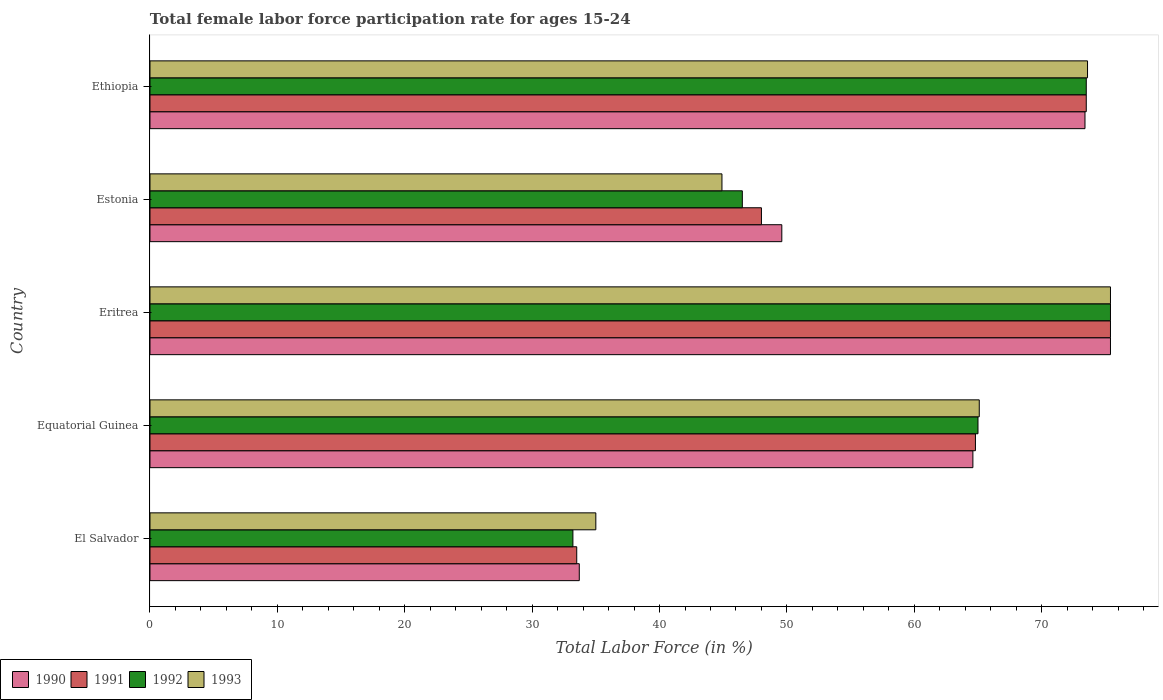How many different coloured bars are there?
Your answer should be very brief. 4. Are the number of bars on each tick of the Y-axis equal?
Provide a succinct answer. Yes. How many bars are there on the 1st tick from the top?
Provide a short and direct response. 4. What is the label of the 4th group of bars from the top?
Your answer should be compact. Equatorial Guinea. What is the female labor force participation rate in 1992 in Equatorial Guinea?
Provide a succinct answer. 65. Across all countries, what is the maximum female labor force participation rate in 1991?
Keep it short and to the point. 75.4. Across all countries, what is the minimum female labor force participation rate in 1991?
Keep it short and to the point. 33.5. In which country was the female labor force participation rate in 1991 maximum?
Your answer should be very brief. Eritrea. In which country was the female labor force participation rate in 1993 minimum?
Provide a short and direct response. El Salvador. What is the total female labor force participation rate in 1992 in the graph?
Provide a succinct answer. 293.6. What is the difference between the female labor force participation rate in 1991 in Estonia and the female labor force participation rate in 1992 in Ethiopia?
Make the answer very short. -25.5. What is the average female labor force participation rate in 1990 per country?
Keep it short and to the point. 59.34. What is the difference between the female labor force participation rate in 1992 and female labor force participation rate in 1990 in Equatorial Guinea?
Offer a terse response. 0.4. In how many countries, is the female labor force participation rate in 1992 greater than 20 %?
Offer a very short reply. 5. What is the ratio of the female labor force participation rate in 1990 in Equatorial Guinea to that in Eritrea?
Your answer should be compact. 0.86. What is the difference between the highest and the second highest female labor force participation rate in 1991?
Make the answer very short. 1.9. What is the difference between the highest and the lowest female labor force participation rate in 1992?
Your answer should be very brief. 42.2. In how many countries, is the female labor force participation rate in 1990 greater than the average female labor force participation rate in 1990 taken over all countries?
Your answer should be compact. 3. Is the sum of the female labor force participation rate in 1992 in El Salvador and Eritrea greater than the maximum female labor force participation rate in 1991 across all countries?
Give a very brief answer. Yes. How many bars are there?
Ensure brevity in your answer.  20. How many countries are there in the graph?
Keep it short and to the point. 5. Are the values on the major ticks of X-axis written in scientific E-notation?
Make the answer very short. No. Does the graph contain grids?
Ensure brevity in your answer.  No. Where does the legend appear in the graph?
Provide a short and direct response. Bottom left. What is the title of the graph?
Give a very brief answer. Total female labor force participation rate for ages 15-24. What is the label or title of the X-axis?
Provide a succinct answer. Total Labor Force (in %). What is the label or title of the Y-axis?
Provide a succinct answer. Country. What is the Total Labor Force (in %) of 1990 in El Salvador?
Provide a succinct answer. 33.7. What is the Total Labor Force (in %) of 1991 in El Salvador?
Your answer should be compact. 33.5. What is the Total Labor Force (in %) of 1992 in El Salvador?
Keep it short and to the point. 33.2. What is the Total Labor Force (in %) in 1990 in Equatorial Guinea?
Provide a succinct answer. 64.6. What is the Total Labor Force (in %) of 1991 in Equatorial Guinea?
Make the answer very short. 64.8. What is the Total Labor Force (in %) of 1993 in Equatorial Guinea?
Keep it short and to the point. 65.1. What is the Total Labor Force (in %) in 1990 in Eritrea?
Give a very brief answer. 75.4. What is the Total Labor Force (in %) in 1991 in Eritrea?
Make the answer very short. 75.4. What is the Total Labor Force (in %) of 1992 in Eritrea?
Ensure brevity in your answer.  75.4. What is the Total Labor Force (in %) of 1993 in Eritrea?
Provide a short and direct response. 75.4. What is the Total Labor Force (in %) in 1990 in Estonia?
Make the answer very short. 49.6. What is the Total Labor Force (in %) of 1992 in Estonia?
Offer a terse response. 46.5. What is the Total Labor Force (in %) in 1993 in Estonia?
Keep it short and to the point. 44.9. What is the Total Labor Force (in %) in 1990 in Ethiopia?
Your response must be concise. 73.4. What is the Total Labor Force (in %) of 1991 in Ethiopia?
Your response must be concise. 73.5. What is the Total Labor Force (in %) of 1992 in Ethiopia?
Your answer should be very brief. 73.5. What is the Total Labor Force (in %) of 1993 in Ethiopia?
Provide a short and direct response. 73.6. Across all countries, what is the maximum Total Labor Force (in %) of 1990?
Provide a succinct answer. 75.4. Across all countries, what is the maximum Total Labor Force (in %) of 1991?
Your response must be concise. 75.4. Across all countries, what is the maximum Total Labor Force (in %) of 1992?
Offer a terse response. 75.4. Across all countries, what is the maximum Total Labor Force (in %) in 1993?
Provide a short and direct response. 75.4. Across all countries, what is the minimum Total Labor Force (in %) of 1990?
Make the answer very short. 33.7. Across all countries, what is the minimum Total Labor Force (in %) of 1991?
Offer a very short reply. 33.5. Across all countries, what is the minimum Total Labor Force (in %) of 1992?
Your answer should be compact. 33.2. What is the total Total Labor Force (in %) of 1990 in the graph?
Offer a very short reply. 296.7. What is the total Total Labor Force (in %) in 1991 in the graph?
Your answer should be very brief. 295.2. What is the total Total Labor Force (in %) in 1992 in the graph?
Your response must be concise. 293.6. What is the total Total Labor Force (in %) in 1993 in the graph?
Your answer should be compact. 294. What is the difference between the Total Labor Force (in %) in 1990 in El Salvador and that in Equatorial Guinea?
Your answer should be compact. -30.9. What is the difference between the Total Labor Force (in %) of 1991 in El Salvador and that in Equatorial Guinea?
Provide a short and direct response. -31.3. What is the difference between the Total Labor Force (in %) of 1992 in El Salvador and that in Equatorial Guinea?
Provide a succinct answer. -31.8. What is the difference between the Total Labor Force (in %) in 1993 in El Salvador and that in Equatorial Guinea?
Keep it short and to the point. -30.1. What is the difference between the Total Labor Force (in %) in 1990 in El Salvador and that in Eritrea?
Provide a succinct answer. -41.7. What is the difference between the Total Labor Force (in %) of 1991 in El Salvador and that in Eritrea?
Make the answer very short. -41.9. What is the difference between the Total Labor Force (in %) of 1992 in El Salvador and that in Eritrea?
Keep it short and to the point. -42.2. What is the difference between the Total Labor Force (in %) of 1993 in El Salvador and that in Eritrea?
Offer a terse response. -40.4. What is the difference between the Total Labor Force (in %) of 1990 in El Salvador and that in Estonia?
Your answer should be compact. -15.9. What is the difference between the Total Labor Force (in %) of 1991 in El Salvador and that in Estonia?
Ensure brevity in your answer.  -14.5. What is the difference between the Total Labor Force (in %) in 1993 in El Salvador and that in Estonia?
Make the answer very short. -9.9. What is the difference between the Total Labor Force (in %) in 1990 in El Salvador and that in Ethiopia?
Your answer should be compact. -39.7. What is the difference between the Total Labor Force (in %) in 1992 in El Salvador and that in Ethiopia?
Make the answer very short. -40.3. What is the difference between the Total Labor Force (in %) in 1993 in El Salvador and that in Ethiopia?
Ensure brevity in your answer.  -38.6. What is the difference between the Total Labor Force (in %) in 1991 in Equatorial Guinea and that in Eritrea?
Your response must be concise. -10.6. What is the difference between the Total Labor Force (in %) of 1993 in Equatorial Guinea and that in Eritrea?
Give a very brief answer. -10.3. What is the difference between the Total Labor Force (in %) in 1990 in Equatorial Guinea and that in Estonia?
Your answer should be very brief. 15. What is the difference between the Total Labor Force (in %) in 1993 in Equatorial Guinea and that in Estonia?
Your response must be concise. 20.2. What is the difference between the Total Labor Force (in %) of 1991 in Equatorial Guinea and that in Ethiopia?
Your answer should be compact. -8.7. What is the difference between the Total Labor Force (in %) of 1993 in Equatorial Guinea and that in Ethiopia?
Offer a very short reply. -8.5. What is the difference between the Total Labor Force (in %) in 1990 in Eritrea and that in Estonia?
Give a very brief answer. 25.8. What is the difference between the Total Labor Force (in %) in 1991 in Eritrea and that in Estonia?
Offer a very short reply. 27.4. What is the difference between the Total Labor Force (in %) in 1992 in Eritrea and that in Estonia?
Your response must be concise. 28.9. What is the difference between the Total Labor Force (in %) of 1993 in Eritrea and that in Estonia?
Provide a short and direct response. 30.5. What is the difference between the Total Labor Force (in %) in 1990 in Eritrea and that in Ethiopia?
Offer a terse response. 2. What is the difference between the Total Labor Force (in %) of 1992 in Eritrea and that in Ethiopia?
Your response must be concise. 1.9. What is the difference between the Total Labor Force (in %) of 1993 in Eritrea and that in Ethiopia?
Your answer should be compact. 1.8. What is the difference between the Total Labor Force (in %) in 1990 in Estonia and that in Ethiopia?
Give a very brief answer. -23.8. What is the difference between the Total Labor Force (in %) of 1991 in Estonia and that in Ethiopia?
Provide a succinct answer. -25.5. What is the difference between the Total Labor Force (in %) of 1993 in Estonia and that in Ethiopia?
Offer a very short reply. -28.7. What is the difference between the Total Labor Force (in %) in 1990 in El Salvador and the Total Labor Force (in %) in 1991 in Equatorial Guinea?
Provide a short and direct response. -31.1. What is the difference between the Total Labor Force (in %) in 1990 in El Salvador and the Total Labor Force (in %) in 1992 in Equatorial Guinea?
Ensure brevity in your answer.  -31.3. What is the difference between the Total Labor Force (in %) in 1990 in El Salvador and the Total Labor Force (in %) in 1993 in Equatorial Guinea?
Give a very brief answer. -31.4. What is the difference between the Total Labor Force (in %) in 1991 in El Salvador and the Total Labor Force (in %) in 1992 in Equatorial Guinea?
Your answer should be very brief. -31.5. What is the difference between the Total Labor Force (in %) of 1991 in El Salvador and the Total Labor Force (in %) of 1993 in Equatorial Guinea?
Your response must be concise. -31.6. What is the difference between the Total Labor Force (in %) of 1992 in El Salvador and the Total Labor Force (in %) of 1993 in Equatorial Guinea?
Your response must be concise. -31.9. What is the difference between the Total Labor Force (in %) in 1990 in El Salvador and the Total Labor Force (in %) in 1991 in Eritrea?
Make the answer very short. -41.7. What is the difference between the Total Labor Force (in %) of 1990 in El Salvador and the Total Labor Force (in %) of 1992 in Eritrea?
Your answer should be compact. -41.7. What is the difference between the Total Labor Force (in %) in 1990 in El Salvador and the Total Labor Force (in %) in 1993 in Eritrea?
Provide a succinct answer. -41.7. What is the difference between the Total Labor Force (in %) in 1991 in El Salvador and the Total Labor Force (in %) in 1992 in Eritrea?
Your answer should be compact. -41.9. What is the difference between the Total Labor Force (in %) in 1991 in El Salvador and the Total Labor Force (in %) in 1993 in Eritrea?
Your answer should be compact. -41.9. What is the difference between the Total Labor Force (in %) in 1992 in El Salvador and the Total Labor Force (in %) in 1993 in Eritrea?
Offer a terse response. -42.2. What is the difference between the Total Labor Force (in %) in 1990 in El Salvador and the Total Labor Force (in %) in 1991 in Estonia?
Offer a terse response. -14.3. What is the difference between the Total Labor Force (in %) in 1990 in El Salvador and the Total Labor Force (in %) in 1992 in Estonia?
Offer a very short reply. -12.8. What is the difference between the Total Labor Force (in %) of 1990 in El Salvador and the Total Labor Force (in %) of 1993 in Estonia?
Offer a terse response. -11.2. What is the difference between the Total Labor Force (in %) of 1991 in El Salvador and the Total Labor Force (in %) of 1993 in Estonia?
Ensure brevity in your answer.  -11.4. What is the difference between the Total Labor Force (in %) in 1990 in El Salvador and the Total Labor Force (in %) in 1991 in Ethiopia?
Give a very brief answer. -39.8. What is the difference between the Total Labor Force (in %) in 1990 in El Salvador and the Total Labor Force (in %) in 1992 in Ethiopia?
Your answer should be compact. -39.8. What is the difference between the Total Labor Force (in %) of 1990 in El Salvador and the Total Labor Force (in %) of 1993 in Ethiopia?
Offer a terse response. -39.9. What is the difference between the Total Labor Force (in %) of 1991 in El Salvador and the Total Labor Force (in %) of 1993 in Ethiopia?
Provide a short and direct response. -40.1. What is the difference between the Total Labor Force (in %) of 1992 in El Salvador and the Total Labor Force (in %) of 1993 in Ethiopia?
Ensure brevity in your answer.  -40.4. What is the difference between the Total Labor Force (in %) of 1990 in Equatorial Guinea and the Total Labor Force (in %) of 1991 in Eritrea?
Your answer should be compact. -10.8. What is the difference between the Total Labor Force (in %) of 1990 in Equatorial Guinea and the Total Labor Force (in %) of 1993 in Eritrea?
Your response must be concise. -10.8. What is the difference between the Total Labor Force (in %) in 1991 in Equatorial Guinea and the Total Labor Force (in %) in 1992 in Eritrea?
Your answer should be very brief. -10.6. What is the difference between the Total Labor Force (in %) in 1991 in Equatorial Guinea and the Total Labor Force (in %) in 1993 in Eritrea?
Offer a terse response. -10.6. What is the difference between the Total Labor Force (in %) of 1990 in Equatorial Guinea and the Total Labor Force (in %) of 1991 in Estonia?
Give a very brief answer. 16.6. What is the difference between the Total Labor Force (in %) of 1991 in Equatorial Guinea and the Total Labor Force (in %) of 1993 in Estonia?
Your answer should be very brief. 19.9. What is the difference between the Total Labor Force (in %) of 1992 in Equatorial Guinea and the Total Labor Force (in %) of 1993 in Estonia?
Your answer should be compact. 20.1. What is the difference between the Total Labor Force (in %) of 1990 in Equatorial Guinea and the Total Labor Force (in %) of 1991 in Ethiopia?
Your answer should be very brief. -8.9. What is the difference between the Total Labor Force (in %) of 1990 in Equatorial Guinea and the Total Labor Force (in %) of 1993 in Ethiopia?
Your response must be concise. -9. What is the difference between the Total Labor Force (in %) of 1991 in Equatorial Guinea and the Total Labor Force (in %) of 1992 in Ethiopia?
Provide a short and direct response. -8.7. What is the difference between the Total Labor Force (in %) of 1991 in Equatorial Guinea and the Total Labor Force (in %) of 1993 in Ethiopia?
Your answer should be compact. -8.8. What is the difference between the Total Labor Force (in %) of 1992 in Equatorial Guinea and the Total Labor Force (in %) of 1993 in Ethiopia?
Your response must be concise. -8.6. What is the difference between the Total Labor Force (in %) in 1990 in Eritrea and the Total Labor Force (in %) in 1991 in Estonia?
Provide a succinct answer. 27.4. What is the difference between the Total Labor Force (in %) in 1990 in Eritrea and the Total Labor Force (in %) in 1992 in Estonia?
Keep it short and to the point. 28.9. What is the difference between the Total Labor Force (in %) in 1990 in Eritrea and the Total Labor Force (in %) in 1993 in Estonia?
Your answer should be very brief. 30.5. What is the difference between the Total Labor Force (in %) of 1991 in Eritrea and the Total Labor Force (in %) of 1992 in Estonia?
Provide a short and direct response. 28.9. What is the difference between the Total Labor Force (in %) of 1991 in Eritrea and the Total Labor Force (in %) of 1993 in Estonia?
Ensure brevity in your answer.  30.5. What is the difference between the Total Labor Force (in %) of 1992 in Eritrea and the Total Labor Force (in %) of 1993 in Estonia?
Offer a terse response. 30.5. What is the difference between the Total Labor Force (in %) in 1990 in Eritrea and the Total Labor Force (in %) in 1991 in Ethiopia?
Your response must be concise. 1.9. What is the difference between the Total Labor Force (in %) of 1990 in Eritrea and the Total Labor Force (in %) of 1992 in Ethiopia?
Ensure brevity in your answer.  1.9. What is the difference between the Total Labor Force (in %) in 1991 in Eritrea and the Total Labor Force (in %) in 1993 in Ethiopia?
Your answer should be compact. 1.8. What is the difference between the Total Labor Force (in %) of 1990 in Estonia and the Total Labor Force (in %) of 1991 in Ethiopia?
Ensure brevity in your answer.  -23.9. What is the difference between the Total Labor Force (in %) of 1990 in Estonia and the Total Labor Force (in %) of 1992 in Ethiopia?
Your response must be concise. -23.9. What is the difference between the Total Labor Force (in %) in 1991 in Estonia and the Total Labor Force (in %) in 1992 in Ethiopia?
Give a very brief answer. -25.5. What is the difference between the Total Labor Force (in %) of 1991 in Estonia and the Total Labor Force (in %) of 1993 in Ethiopia?
Your response must be concise. -25.6. What is the difference between the Total Labor Force (in %) of 1992 in Estonia and the Total Labor Force (in %) of 1993 in Ethiopia?
Your answer should be compact. -27.1. What is the average Total Labor Force (in %) in 1990 per country?
Give a very brief answer. 59.34. What is the average Total Labor Force (in %) in 1991 per country?
Keep it short and to the point. 59.04. What is the average Total Labor Force (in %) in 1992 per country?
Make the answer very short. 58.72. What is the average Total Labor Force (in %) of 1993 per country?
Keep it short and to the point. 58.8. What is the difference between the Total Labor Force (in %) in 1990 and Total Labor Force (in %) in 1991 in El Salvador?
Make the answer very short. 0.2. What is the difference between the Total Labor Force (in %) of 1990 and Total Labor Force (in %) of 1993 in El Salvador?
Make the answer very short. -1.3. What is the difference between the Total Labor Force (in %) in 1991 and Total Labor Force (in %) in 1993 in El Salvador?
Keep it short and to the point. -1.5. What is the difference between the Total Labor Force (in %) in 1992 and Total Labor Force (in %) in 1993 in El Salvador?
Ensure brevity in your answer.  -1.8. What is the difference between the Total Labor Force (in %) in 1991 and Total Labor Force (in %) in 1992 in Equatorial Guinea?
Your response must be concise. -0.2. What is the difference between the Total Labor Force (in %) of 1991 and Total Labor Force (in %) of 1993 in Equatorial Guinea?
Keep it short and to the point. -0.3. What is the difference between the Total Labor Force (in %) in 1990 and Total Labor Force (in %) in 1991 in Eritrea?
Give a very brief answer. 0. What is the difference between the Total Labor Force (in %) of 1990 and Total Labor Force (in %) of 1992 in Eritrea?
Your answer should be very brief. 0. What is the difference between the Total Labor Force (in %) of 1990 and Total Labor Force (in %) of 1993 in Eritrea?
Provide a succinct answer. 0. What is the difference between the Total Labor Force (in %) in 1992 and Total Labor Force (in %) in 1993 in Eritrea?
Ensure brevity in your answer.  0. What is the difference between the Total Labor Force (in %) in 1990 and Total Labor Force (in %) in 1991 in Estonia?
Ensure brevity in your answer.  1.6. What is the difference between the Total Labor Force (in %) in 1990 and Total Labor Force (in %) in 1992 in Estonia?
Provide a succinct answer. 3.1. What is the difference between the Total Labor Force (in %) in 1990 and Total Labor Force (in %) in 1993 in Estonia?
Provide a succinct answer. 4.7. What is the difference between the Total Labor Force (in %) of 1991 and Total Labor Force (in %) of 1993 in Estonia?
Offer a very short reply. 3.1. What is the difference between the Total Labor Force (in %) of 1990 and Total Labor Force (in %) of 1991 in Ethiopia?
Make the answer very short. -0.1. What is the ratio of the Total Labor Force (in %) of 1990 in El Salvador to that in Equatorial Guinea?
Ensure brevity in your answer.  0.52. What is the ratio of the Total Labor Force (in %) of 1991 in El Salvador to that in Equatorial Guinea?
Your answer should be very brief. 0.52. What is the ratio of the Total Labor Force (in %) of 1992 in El Salvador to that in Equatorial Guinea?
Your answer should be very brief. 0.51. What is the ratio of the Total Labor Force (in %) of 1993 in El Salvador to that in Equatorial Guinea?
Your response must be concise. 0.54. What is the ratio of the Total Labor Force (in %) of 1990 in El Salvador to that in Eritrea?
Offer a very short reply. 0.45. What is the ratio of the Total Labor Force (in %) of 1991 in El Salvador to that in Eritrea?
Provide a short and direct response. 0.44. What is the ratio of the Total Labor Force (in %) of 1992 in El Salvador to that in Eritrea?
Offer a terse response. 0.44. What is the ratio of the Total Labor Force (in %) in 1993 in El Salvador to that in Eritrea?
Your answer should be very brief. 0.46. What is the ratio of the Total Labor Force (in %) in 1990 in El Salvador to that in Estonia?
Provide a short and direct response. 0.68. What is the ratio of the Total Labor Force (in %) of 1991 in El Salvador to that in Estonia?
Provide a short and direct response. 0.7. What is the ratio of the Total Labor Force (in %) of 1992 in El Salvador to that in Estonia?
Your response must be concise. 0.71. What is the ratio of the Total Labor Force (in %) of 1993 in El Salvador to that in Estonia?
Your answer should be very brief. 0.78. What is the ratio of the Total Labor Force (in %) of 1990 in El Salvador to that in Ethiopia?
Provide a short and direct response. 0.46. What is the ratio of the Total Labor Force (in %) in 1991 in El Salvador to that in Ethiopia?
Your response must be concise. 0.46. What is the ratio of the Total Labor Force (in %) of 1992 in El Salvador to that in Ethiopia?
Provide a succinct answer. 0.45. What is the ratio of the Total Labor Force (in %) in 1993 in El Salvador to that in Ethiopia?
Offer a terse response. 0.48. What is the ratio of the Total Labor Force (in %) of 1990 in Equatorial Guinea to that in Eritrea?
Make the answer very short. 0.86. What is the ratio of the Total Labor Force (in %) of 1991 in Equatorial Guinea to that in Eritrea?
Your answer should be very brief. 0.86. What is the ratio of the Total Labor Force (in %) of 1992 in Equatorial Guinea to that in Eritrea?
Make the answer very short. 0.86. What is the ratio of the Total Labor Force (in %) in 1993 in Equatorial Guinea to that in Eritrea?
Your response must be concise. 0.86. What is the ratio of the Total Labor Force (in %) of 1990 in Equatorial Guinea to that in Estonia?
Provide a short and direct response. 1.3. What is the ratio of the Total Labor Force (in %) of 1991 in Equatorial Guinea to that in Estonia?
Your response must be concise. 1.35. What is the ratio of the Total Labor Force (in %) in 1992 in Equatorial Guinea to that in Estonia?
Offer a terse response. 1.4. What is the ratio of the Total Labor Force (in %) of 1993 in Equatorial Guinea to that in Estonia?
Ensure brevity in your answer.  1.45. What is the ratio of the Total Labor Force (in %) in 1990 in Equatorial Guinea to that in Ethiopia?
Your response must be concise. 0.88. What is the ratio of the Total Labor Force (in %) of 1991 in Equatorial Guinea to that in Ethiopia?
Keep it short and to the point. 0.88. What is the ratio of the Total Labor Force (in %) of 1992 in Equatorial Guinea to that in Ethiopia?
Offer a terse response. 0.88. What is the ratio of the Total Labor Force (in %) of 1993 in Equatorial Guinea to that in Ethiopia?
Provide a short and direct response. 0.88. What is the ratio of the Total Labor Force (in %) in 1990 in Eritrea to that in Estonia?
Make the answer very short. 1.52. What is the ratio of the Total Labor Force (in %) in 1991 in Eritrea to that in Estonia?
Provide a short and direct response. 1.57. What is the ratio of the Total Labor Force (in %) of 1992 in Eritrea to that in Estonia?
Offer a terse response. 1.62. What is the ratio of the Total Labor Force (in %) in 1993 in Eritrea to that in Estonia?
Offer a very short reply. 1.68. What is the ratio of the Total Labor Force (in %) in 1990 in Eritrea to that in Ethiopia?
Give a very brief answer. 1.03. What is the ratio of the Total Labor Force (in %) in 1991 in Eritrea to that in Ethiopia?
Ensure brevity in your answer.  1.03. What is the ratio of the Total Labor Force (in %) of 1992 in Eritrea to that in Ethiopia?
Offer a terse response. 1.03. What is the ratio of the Total Labor Force (in %) of 1993 in Eritrea to that in Ethiopia?
Make the answer very short. 1.02. What is the ratio of the Total Labor Force (in %) in 1990 in Estonia to that in Ethiopia?
Your answer should be very brief. 0.68. What is the ratio of the Total Labor Force (in %) in 1991 in Estonia to that in Ethiopia?
Keep it short and to the point. 0.65. What is the ratio of the Total Labor Force (in %) in 1992 in Estonia to that in Ethiopia?
Give a very brief answer. 0.63. What is the ratio of the Total Labor Force (in %) of 1993 in Estonia to that in Ethiopia?
Provide a short and direct response. 0.61. What is the difference between the highest and the second highest Total Labor Force (in %) of 1990?
Your response must be concise. 2. What is the difference between the highest and the second highest Total Labor Force (in %) in 1991?
Offer a terse response. 1.9. What is the difference between the highest and the second highest Total Labor Force (in %) of 1992?
Offer a very short reply. 1.9. What is the difference between the highest and the second highest Total Labor Force (in %) of 1993?
Keep it short and to the point. 1.8. What is the difference between the highest and the lowest Total Labor Force (in %) in 1990?
Provide a succinct answer. 41.7. What is the difference between the highest and the lowest Total Labor Force (in %) in 1991?
Make the answer very short. 41.9. What is the difference between the highest and the lowest Total Labor Force (in %) of 1992?
Make the answer very short. 42.2. What is the difference between the highest and the lowest Total Labor Force (in %) in 1993?
Provide a succinct answer. 40.4. 